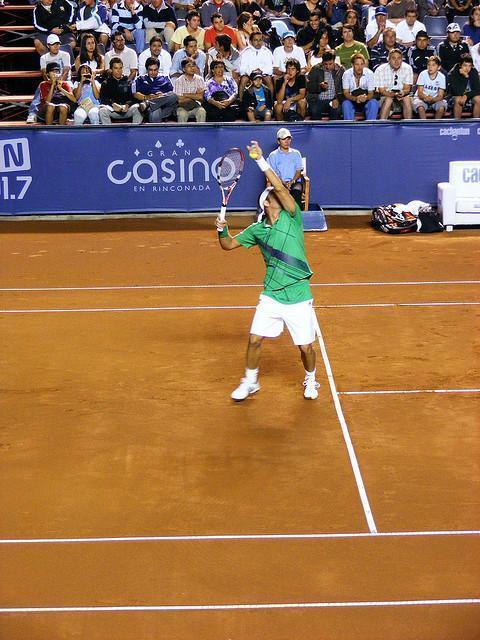How many people are there?
Give a very brief answer. 3. How many dogs are on he bench in this image?
Give a very brief answer. 0. 